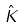<formula> <loc_0><loc_0><loc_500><loc_500>\hat { K }</formula> 